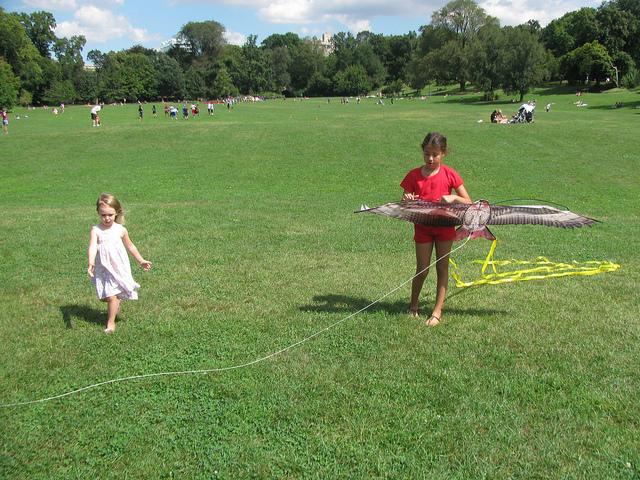Is the kite being flown?
Short answer required. No. Are they wearing shoes?
Quick response, please. No. What color is the little blonde girl's dress?
Quick response, please. White. 